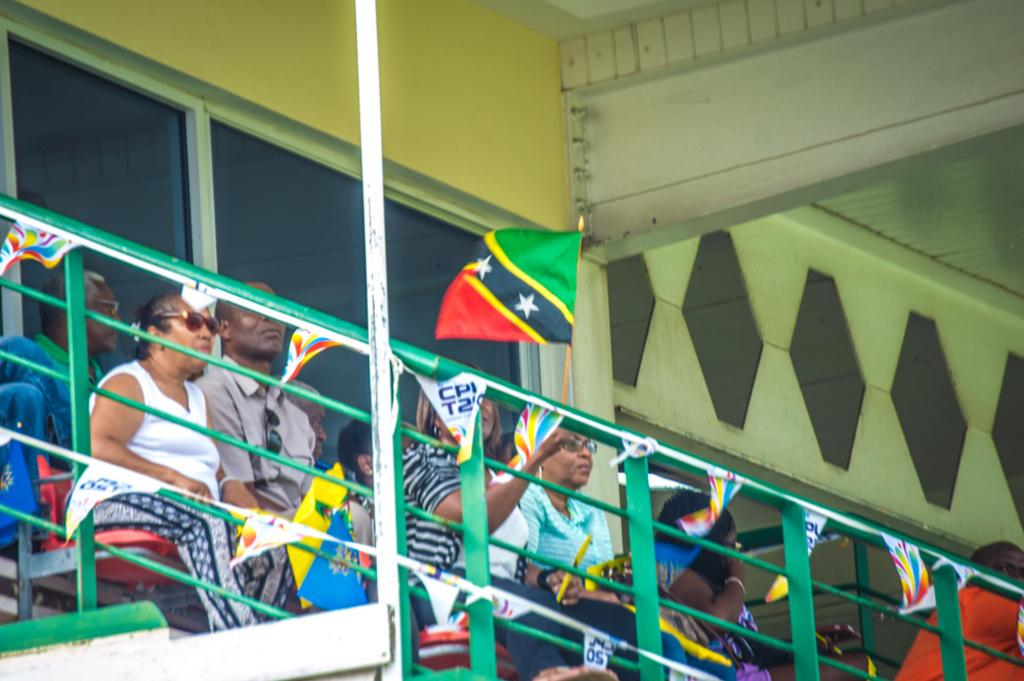<image>
Relay a brief, clear account of the picture shown. Several people are attending an even that has a banner hanging from the railing with the letters CPI on some of the triangles. 